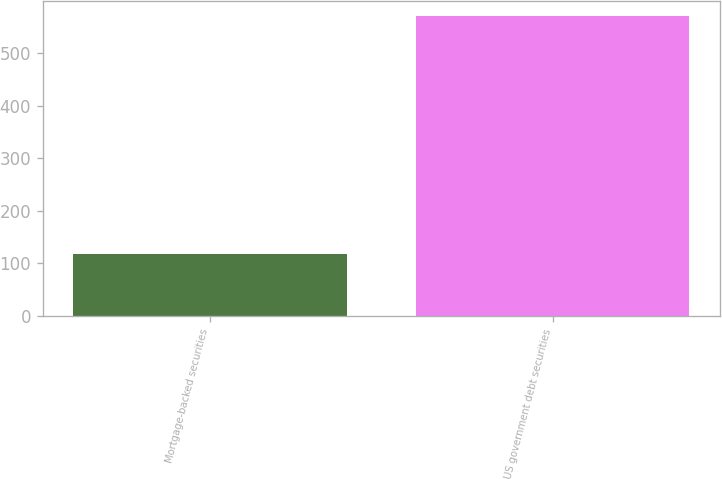<chart> <loc_0><loc_0><loc_500><loc_500><bar_chart><fcel>Mortgage-backed securities<fcel>US government debt securities<nl><fcel>117<fcel>571<nl></chart> 